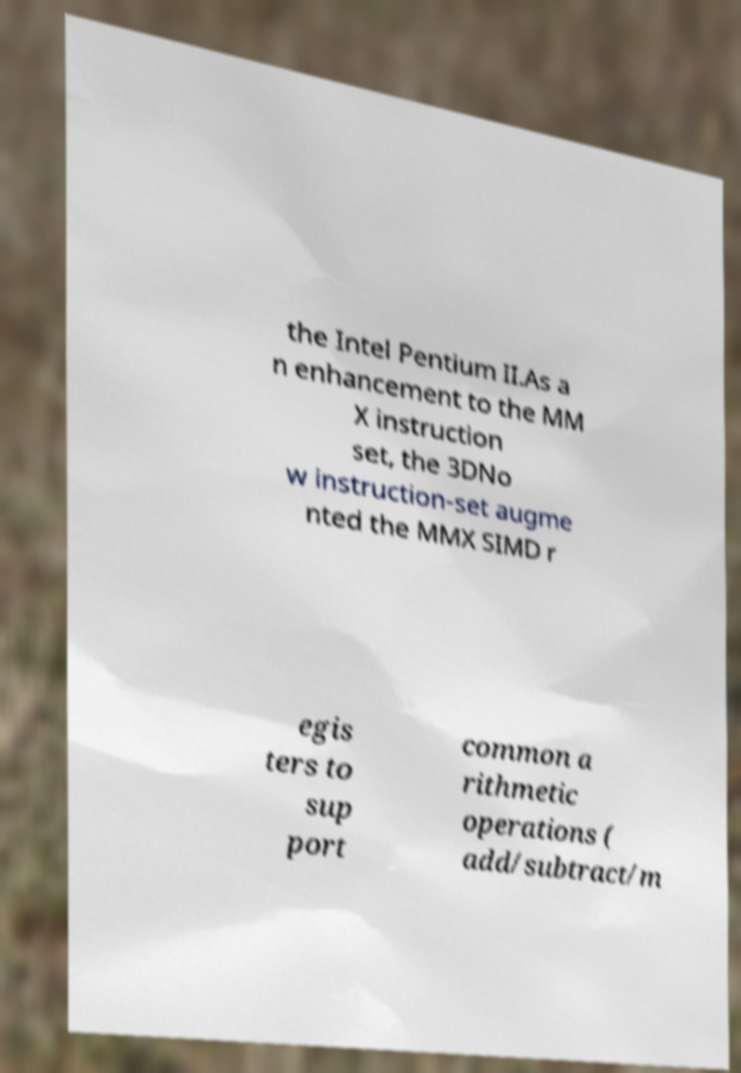For documentation purposes, I need the text within this image transcribed. Could you provide that? the Intel Pentium II.As a n enhancement to the MM X instruction set, the 3DNo w instruction-set augme nted the MMX SIMD r egis ters to sup port common a rithmetic operations ( add/subtract/m 